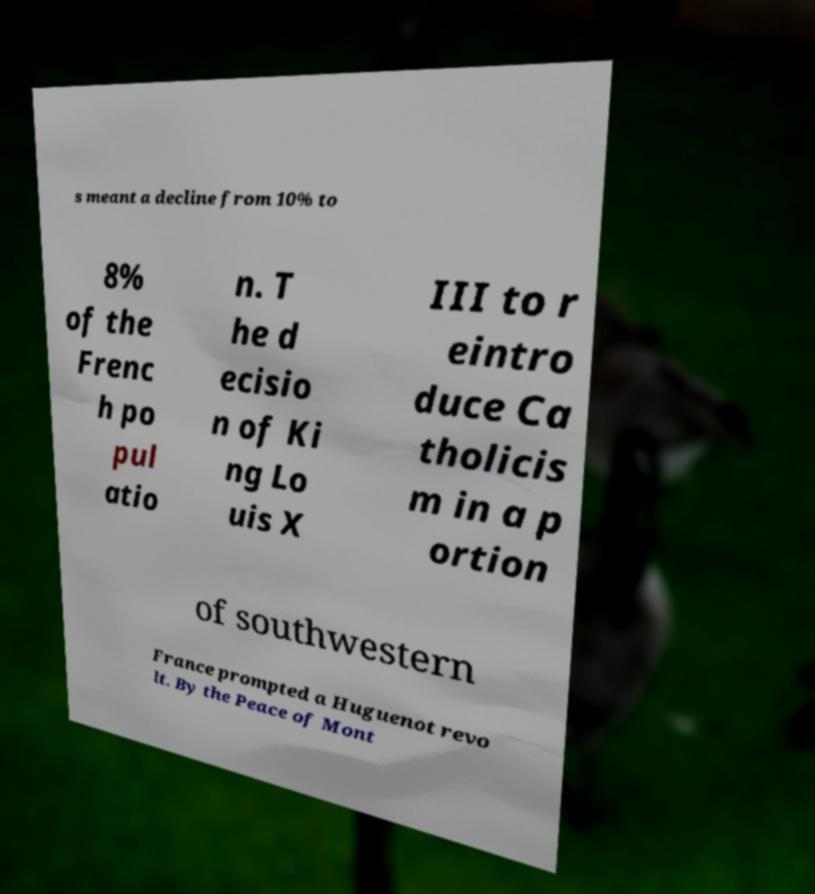Can you accurately transcribe the text from the provided image for me? s meant a decline from 10% to 8% of the Frenc h po pul atio n. T he d ecisio n of Ki ng Lo uis X III to r eintro duce Ca tholicis m in a p ortion of southwestern France prompted a Huguenot revo lt. By the Peace of Mont 